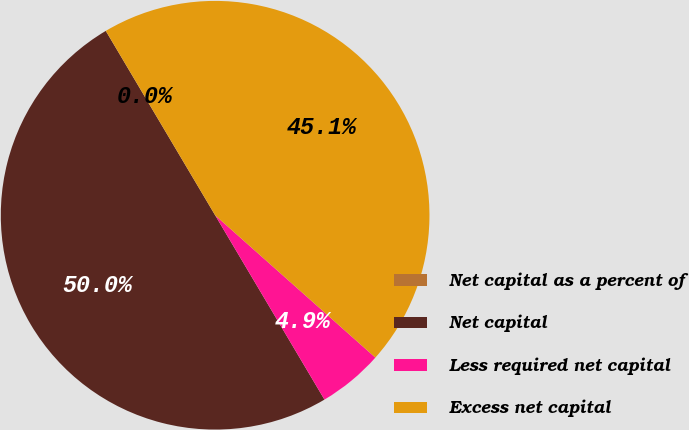Convert chart. <chart><loc_0><loc_0><loc_500><loc_500><pie_chart><fcel>Net capital as a percent of<fcel>Net capital<fcel>Less required net capital<fcel>Excess net capital<nl><fcel>0.0%<fcel>50.0%<fcel>4.92%<fcel>45.08%<nl></chart> 